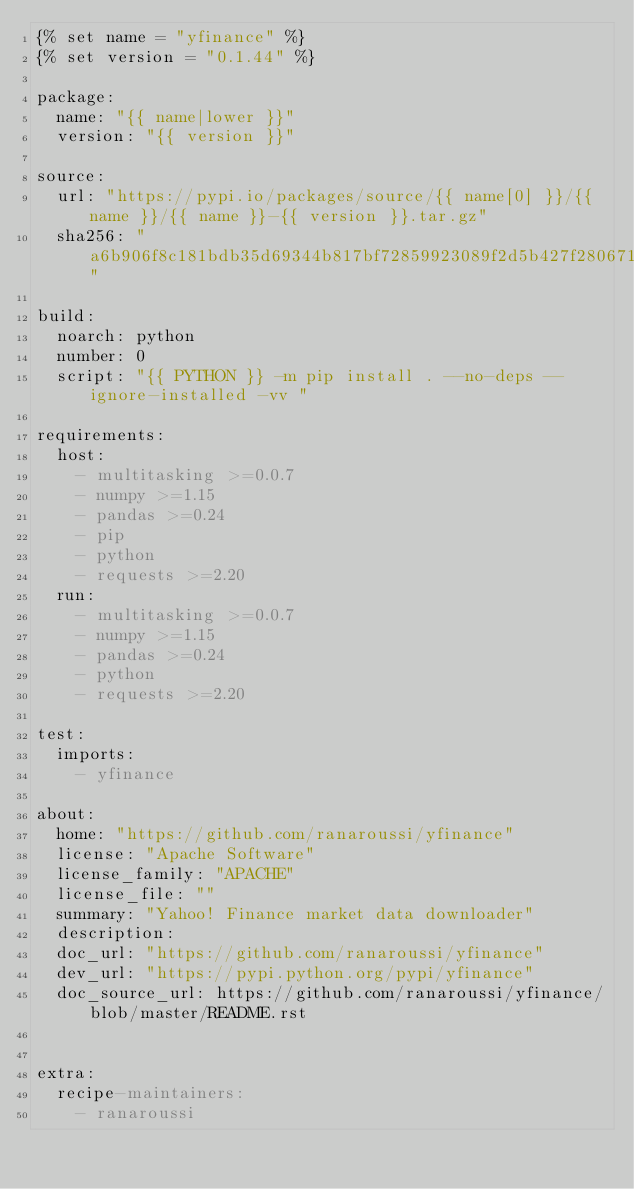<code> <loc_0><loc_0><loc_500><loc_500><_YAML_>{% set name = "yfinance" %}
{% set version = "0.1.44" %}

package:
  name: "{{ name|lower }}"
  version: "{{ version }}"

source:
  url: "https://pypi.io/packages/source/{{ name[0] }}/{{ name }}/{{ name }}-{{ version }}.tar.gz"
  sha256: "a6b906f8c181bdb35d69344b817bf72859923089f2d5b427f2806718ea92e3b9"

build:
  noarch: python
  number: 0
  script: "{{ PYTHON }} -m pip install . --no-deps --ignore-installed -vv "

requirements:
  host:
    - multitasking >=0.0.7
    - numpy >=1.15
    - pandas >=0.24
    - pip
    - python
    - requests >=2.20
  run:
    - multitasking >=0.0.7
    - numpy >=1.15
    - pandas >=0.24
    - python
    - requests >=2.20

test:
  imports:
    - yfinance

about:
  home: "https://github.com/ranaroussi/yfinance"
  license: "Apache Software"
  license_family: "APACHE"
  license_file: ""
  summary: "Yahoo! Finance market data downloader"
  description:
  doc_url: "https://github.com/ranaroussi/yfinance"
  dev_url: "https://pypi.python.org/pypi/yfinance"
  doc_source_url: https://github.com/ranaroussi/yfinance/blob/master/README.rst


extra:
  recipe-maintainers:
    - ranaroussi
</code> 